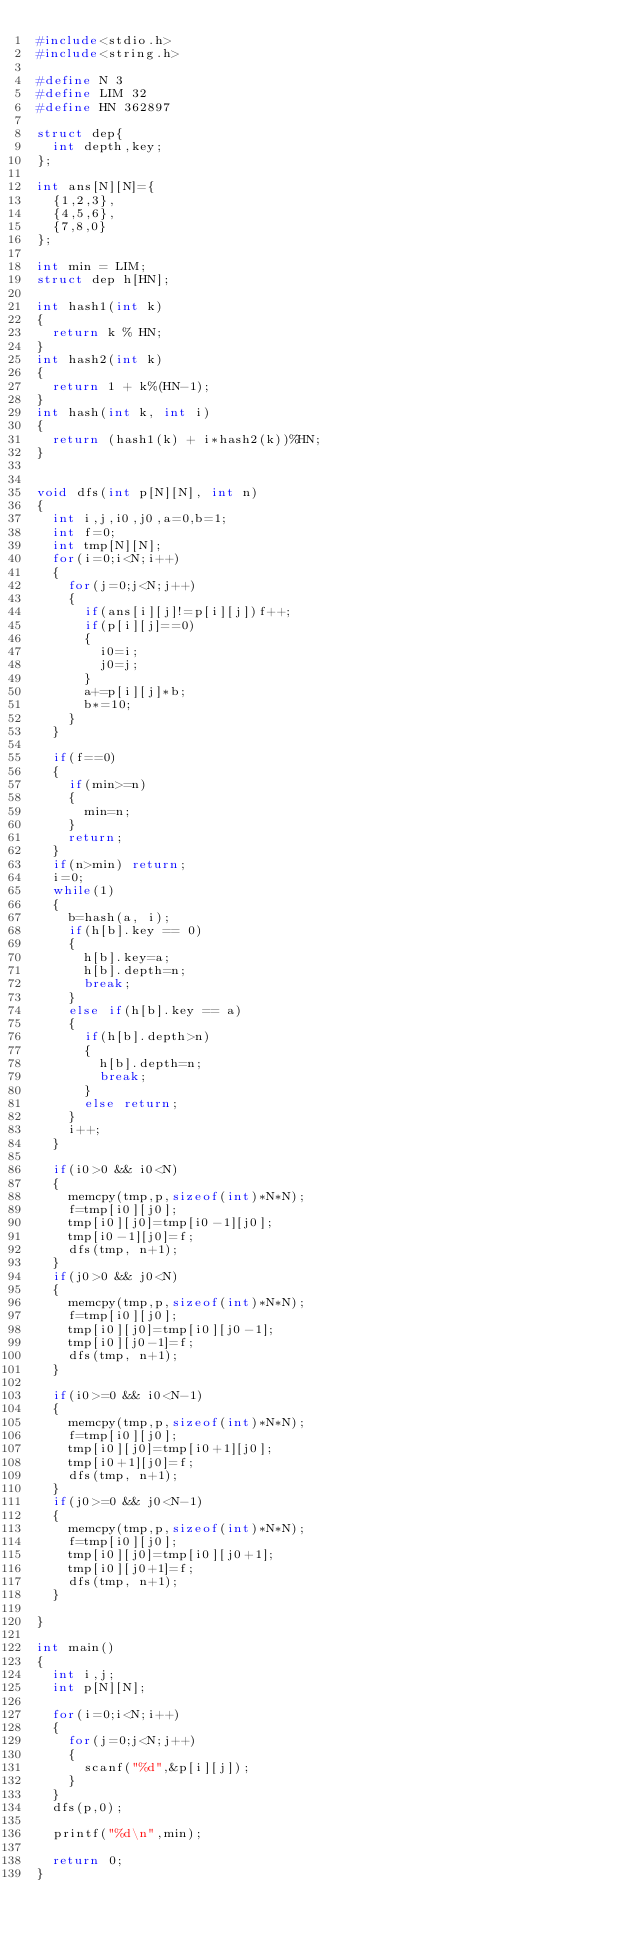Convert code to text. <code><loc_0><loc_0><loc_500><loc_500><_C_>#include<stdio.h>
#include<string.h>

#define N 3
#define LIM 32
#define HN 362897

struct dep{
  int depth,key;
};

int ans[N][N]={
  {1,2,3},
  {4,5,6},
  {7,8,0}
};

int min = LIM;
struct dep h[HN];

int hash1(int k)
{
  return k % HN;
}
int hash2(int k)
{
  return 1 + k%(HN-1);
}
int hash(int k, int i)
{
  return (hash1(k) + i*hash2(k))%HN;
}


void dfs(int p[N][N], int n)
{
  int i,j,i0,j0,a=0,b=1;
  int f=0;
  int tmp[N][N];
  for(i=0;i<N;i++)
  {
    for(j=0;j<N;j++)
    {
      if(ans[i][j]!=p[i][j])f++;
      if(p[i][j]==0)
      {
        i0=i;
        j0=j;
      }
      a+=p[i][j]*b;
      b*=10;
    }
  }

  if(f==0)
  {
    if(min>=n)
    {
      min=n;
    }
    return;
  }
  if(n>min) return;
  i=0;
  while(1)
  {
    b=hash(a, i);
    if(h[b].key == 0)
    {
      h[b].key=a;
      h[b].depth=n;
      break;
    }
    else if(h[b].key == a)
    {
      if(h[b].depth>n)
      {
        h[b].depth=n;
        break;
      }
      else return;
    }
    i++;
  }

  if(i0>0 && i0<N)
  {
    memcpy(tmp,p,sizeof(int)*N*N);
    f=tmp[i0][j0];
    tmp[i0][j0]=tmp[i0-1][j0];
    tmp[i0-1][j0]=f;
    dfs(tmp, n+1);
  }
  if(j0>0 && j0<N)
  {
    memcpy(tmp,p,sizeof(int)*N*N);
    f=tmp[i0][j0];
    tmp[i0][j0]=tmp[i0][j0-1];
    tmp[i0][j0-1]=f;
    dfs(tmp, n+1);
  }

  if(i0>=0 && i0<N-1)
  {
    memcpy(tmp,p,sizeof(int)*N*N);
    f=tmp[i0][j0];
    tmp[i0][j0]=tmp[i0+1][j0];
    tmp[i0+1][j0]=f;
    dfs(tmp, n+1);
  }
  if(j0>=0 && j0<N-1)
  {
    memcpy(tmp,p,sizeof(int)*N*N);
    f=tmp[i0][j0];
    tmp[i0][j0]=tmp[i0][j0+1];
    tmp[i0][j0+1]=f;
    dfs(tmp, n+1);
  }

}

int main()
{
  int i,j;
  int p[N][N];

  for(i=0;i<N;i++)
  {
    for(j=0;j<N;j++)
    {
      scanf("%d",&p[i][j]);
    }
  }
  dfs(p,0);

  printf("%d\n",min);

  return 0;
}

</code> 